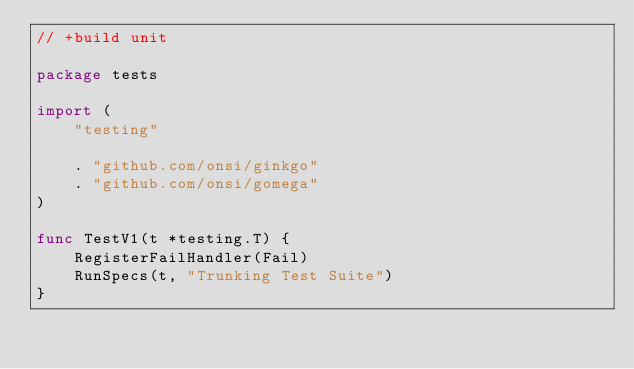Convert code to text. <code><loc_0><loc_0><loc_500><loc_500><_Go_>// +build unit

package tests

import (
	"testing"

	. "github.com/onsi/ginkgo"
	. "github.com/onsi/gomega"
)

func TestV1(t *testing.T) {
	RegisterFailHandler(Fail)
	RunSpecs(t, "Trunking Test Suite")
}
</code> 